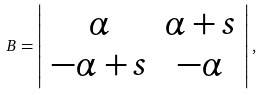Convert formula to latex. <formula><loc_0><loc_0><loc_500><loc_500>B = \left | \begin{array} { c c } { \alpha } & { \alpha + s } \\ { - \alpha + s } & { - \alpha } \end{array} \right | ,</formula> 